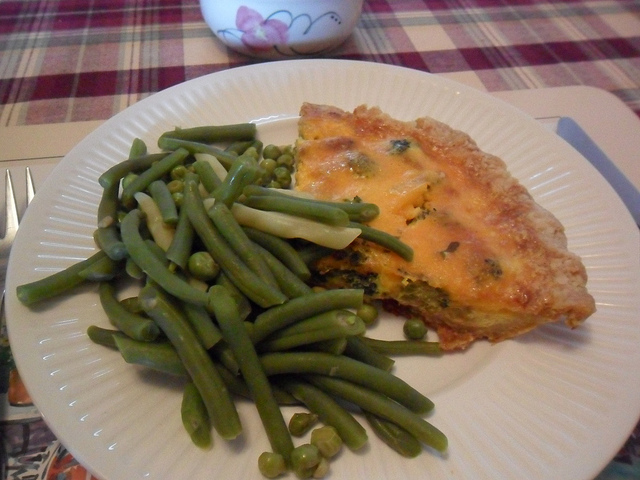<image>Was this dinner from a buffet? It is not clear if the dinner was from a buffet. Was this dinner from a buffet? It is difficult to tell if this dinner was from a buffet. It could be both yes or no. 